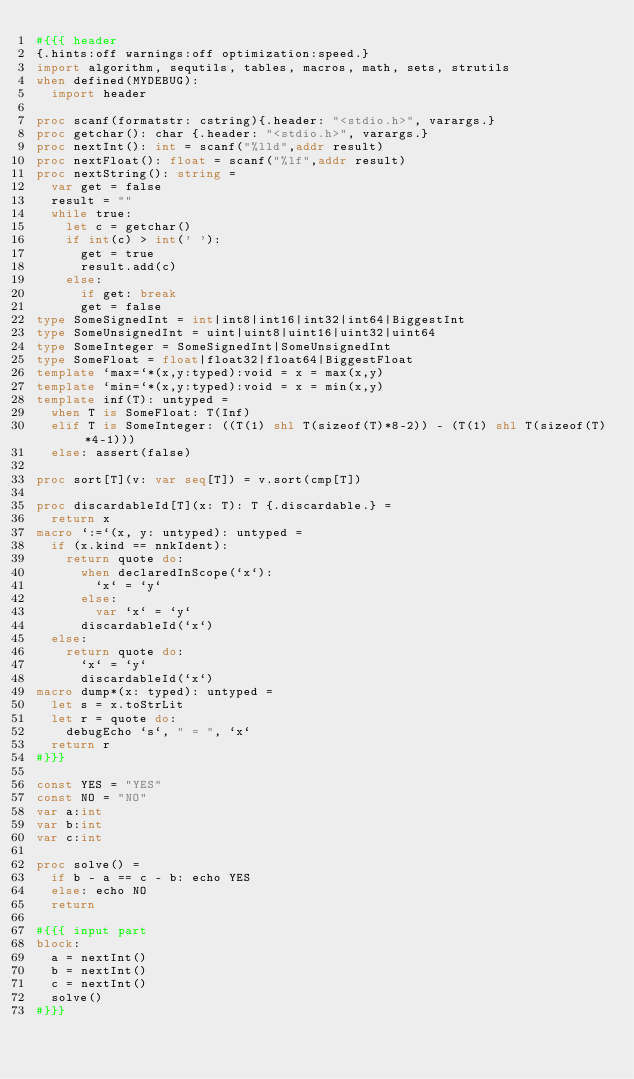<code> <loc_0><loc_0><loc_500><loc_500><_Nim_>#{{{ header
{.hints:off warnings:off optimization:speed.}
import algorithm, sequtils, tables, macros, math, sets, strutils
when defined(MYDEBUG):
  import header

proc scanf(formatstr: cstring){.header: "<stdio.h>", varargs.}
proc getchar(): char {.header: "<stdio.h>", varargs.}
proc nextInt(): int = scanf("%lld",addr result)
proc nextFloat(): float = scanf("%lf",addr result)
proc nextString(): string =
  var get = false
  result = ""
  while true:
    let c = getchar()
    if int(c) > int(' '):
      get = true
      result.add(c)
    else:
      if get: break
      get = false
type SomeSignedInt = int|int8|int16|int32|int64|BiggestInt
type SomeUnsignedInt = uint|uint8|uint16|uint32|uint64
type SomeInteger = SomeSignedInt|SomeUnsignedInt
type SomeFloat = float|float32|float64|BiggestFloat
template `max=`*(x,y:typed):void = x = max(x,y)
template `min=`*(x,y:typed):void = x = min(x,y)
template inf(T): untyped = 
  when T is SomeFloat: T(Inf)
  elif T is SomeInteger: ((T(1) shl T(sizeof(T)*8-2)) - (T(1) shl T(sizeof(T)*4-1)))
  else: assert(false)

proc sort[T](v: var seq[T]) = v.sort(cmp[T])

proc discardableId[T](x: T): T {.discardable.} =
  return x
macro `:=`(x, y: untyped): untyped =
  if (x.kind == nnkIdent):
    return quote do:
      when declaredInScope(`x`):
        `x` = `y`
      else:
        var `x` = `y`
      discardableId(`x`)
  else:
    return quote do:
      `x` = `y`
      discardableId(`x`)
macro dump*(x: typed): untyped =
  let s = x.toStrLit
  let r = quote do:
    debugEcho `s`, " = ", `x`
  return r
#}}}

const YES = "YES"
const NO = "NO"
var a:int
var b:int
var c:int

proc solve() =
  if b - a == c - b: echo YES
  else: echo NO
  return

#{{{ input part
block:
  a = nextInt()
  b = nextInt()
  c = nextInt()
  solve()
#}}}
</code> 